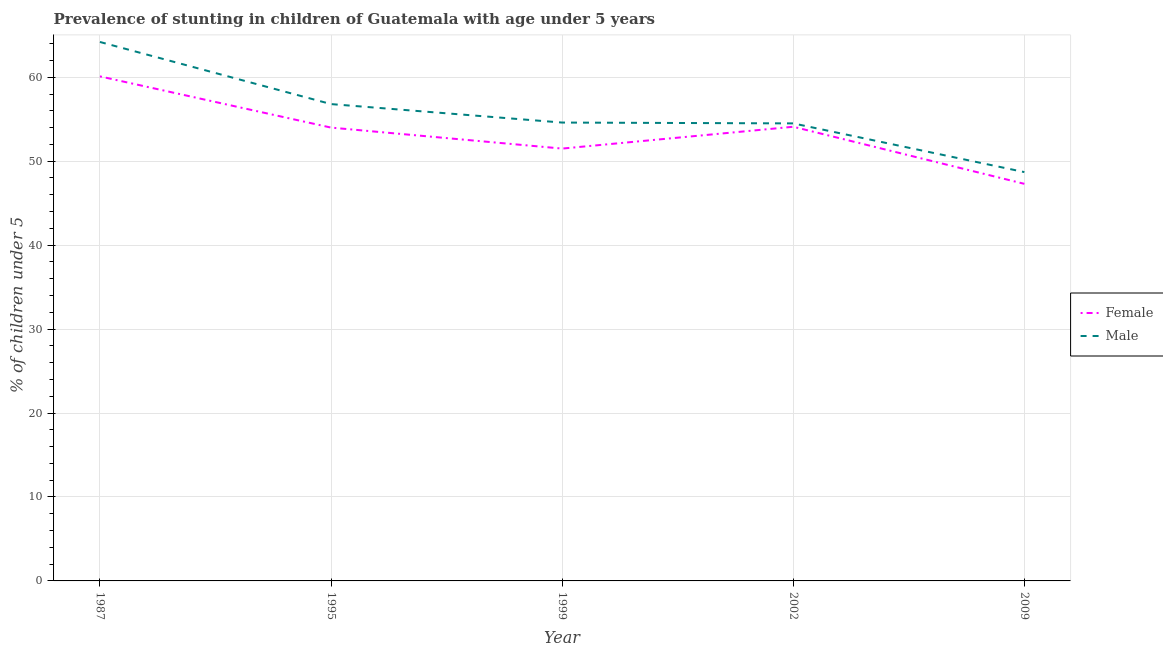Does the line corresponding to percentage of stunted male children intersect with the line corresponding to percentage of stunted female children?
Make the answer very short. No. Is the number of lines equal to the number of legend labels?
Your answer should be very brief. Yes. What is the percentage of stunted female children in 2009?
Give a very brief answer. 47.3. Across all years, what is the maximum percentage of stunted female children?
Offer a terse response. 60.1. Across all years, what is the minimum percentage of stunted male children?
Offer a very short reply. 48.7. What is the total percentage of stunted male children in the graph?
Offer a terse response. 278.8. What is the difference between the percentage of stunted male children in 1999 and that in 2009?
Keep it short and to the point. 5.9. What is the difference between the percentage of stunted male children in 2009 and the percentage of stunted female children in 1999?
Give a very brief answer. -2.8. What is the average percentage of stunted male children per year?
Offer a very short reply. 55.76. In the year 1999, what is the difference between the percentage of stunted female children and percentage of stunted male children?
Provide a short and direct response. -3.1. In how many years, is the percentage of stunted male children greater than 14 %?
Offer a very short reply. 5. What is the ratio of the percentage of stunted male children in 1995 to that in 2009?
Your response must be concise. 1.17. Is the difference between the percentage of stunted female children in 1995 and 2002 greater than the difference between the percentage of stunted male children in 1995 and 2002?
Your response must be concise. No. What is the difference between the highest and the second highest percentage of stunted male children?
Provide a short and direct response. 7.4. What is the difference between the highest and the lowest percentage of stunted female children?
Ensure brevity in your answer.  12.8. In how many years, is the percentage of stunted female children greater than the average percentage of stunted female children taken over all years?
Keep it short and to the point. 3. Is the percentage of stunted male children strictly greater than the percentage of stunted female children over the years?
Your answer should be compact. Yes. How many lines are there?
Make the answer very short. 2. What is the difference between two consecutive major ticks on the Y-axis?
Give a very brief answer. 10. Does the graph contain grids?
Provide a succinct answer. Yes. How many legend labels are there?
Your answer should be very brief. 2. What is the title of the graph?
Provide a short and direct response. Prevalence of stunting in children of Guatemala with age under 5 years. What is the label or title of the X-axis?
Give a very brief answer. Year. What is the label or title of the Y-axis?
Your response must be concise.  % of children under 5. What is the  % of children under 5 of Female in 1987?
Offer a very short reply. 60.1. What is the  % of children under 5 of Male in 1987?
Ensure brevity in your answer.  64.2. What is the  % of children under 5 in Male in 1995?
Make the answer very short. 56.8. What is the  % of children under 5 of Female in 1999?
Provide a succinct answer. 51.5. What is the  % of children under 5 in Male in 1999?
Make the answer very short. 54.6. What is the  % of children under 5 in Female in 2002?
Provide a short and direct response. 54.1. What is the  % of children under 5 in Male in 2002?
Your answer should be compact. 54.5. What is the  % of children under 5 in Female in 2009?
Offer a terse response. 47.3. What is the  % of children under 5 in Male in 2009?
Provide a short and direct response. 48.7. Across all years, what is the maximum  % of children under 5 in Female?
Your answer should be very brief. 60.1. Across all years, what is the maximum  % of children under 5 in Male?
Your answer should be very brief. 64.2. Across all years, what is the minimum  % of children under 5 of Female?
Your answer should be very brief. 47.3. Across all years, what is the minimum  % of children under 5 in Male?
Keep it short and to the point. 48.7. What is the total  % of children under 5 of Female in the graph?
Make the answer very short. 267. What is the total  % of children under 5 in Male in the graph?
Ensure brevity in your answer.  278.8. What is the difference between the  % of children under 5 in Female in 1987 and that in 1995?
Your response must be concise. 6.1. What is the difference between the  % of children under 5 of Female in 1987 and that in 2002?
Your response must be concise. 6. What is the difference between the  % of children under 5 in Male in 1987 and that in 2002?
Give a very brief answer. 9.7. What is the difference between the  % of children under 5 of Female in 1987 and that in 2009?
Make the answer very short. 12.8. What is the difference between the  % of children under 5 of Male in 1995 and that in 1999?
Provide a short and direct response. 2.2. What is the difference between the  % of children under 5 of Male in 1995 and that in 2009?
Your response must be concise. 8.1. What is the difference between the  % of children under 5 in Female in 1999 and that in 2002?
Your answer should be very brief. -2.6. What is the difference between the  % of children under 5 of Female in 1999 and that in 2009?
Your response must be concise. 4.2. What is the difference between the  % of children under 5 of Male in 1999 and that in 2009?
Keep it short and to the point. 5.9. What is the difference between the  % of children under 5 in Male in 2002 and that in 2009?
Ensure brevity in your answer.  5.8. What is the difference between the  % of children under 5 of Female in 1987 and the  % of children under 5 of Male in 1999?
Offer a terse response. 5.5. What is the difference between the  % of children under 5 of Female in 1995 and the  % of children under 5 of Male in 1999?
Offer a terse response. -0.6. What is the difference between the  % of children under 5 of Female in 1995 and the  % of children under 5 of Male in 2009?
Offer a very short reply. 5.3. What is the difference between the  % of children under 5 of Female in 1999 and the  % of children under 5 of Male in 2002?
Keep it short and to the point. -3. What is the difference between the  % of children under 5 in Female in 2002 and the  % of children under 5 in Male in 2009?
Keep it short and to the point. 5.4. What is the average  % of children under 5 of Female per year?
Your response must be concise. 53.4. What is the average  % of children under 5 in Male per year?
Your response must be concise. 55.76. In the year 2009, what is the difference between the  % of children under 5 in Female and  % of children under 5 in Male?
Give a very brief answer. -1.4. What is the ratio of the  % of children under 5 of Female in 1987 to that in 1995?
Ensure brevity in your answer.  1.11. What is the ratio of the  % of children under 5 in Male in 1987 to that in 1995?
Your answer should be very brief. 1.13. What is the ratio of the  % of children under 5 in Female in 1987 to that in 1999?
Give a very brief answer. 1.17. What is the ratio of the  % of children under 5 in Male in 1987 to that in 1999?
Provide a succinct answer. 1.18. What is the ratio of the  % of children under 5 in Female in 1987 to that in 2002?
Make the answer very short. 1.11. What is the ratio of the  % of children under 5 of Male in 1987 to that in 2002?
Offer a very short reply. 1.18. What is the ratio of the  % of children under 5 of Female in 1987 to that in 2009?
Give a very brief answer. 1.27. What is the ratio of the  % of children under 5 in Male in 1987 to that in 2009?
Offer a terse response. 1.32. What is the ratio of the  % of children under 5 in Female in 1995 to that in 1999?
Provide a short and direct response. 1.05. What is the ratio of the  % of children under 5 of Male in 1995 to that in 1999?
Your response must be concise. 1.04. What is the ratio of the  % of children under 5 of Male in 1995 to that in 2002?
Your answer should be very brief. 1.04. What is the ratio of the  % of children under 5 in Female in 1995 to that in 2009?
Give a very brief answer. 1.14. What is the ratio of the  % of children under 5 of Male in 1995 to that in 2009?
Provide a succinct answer. 1.17. What is the ratio of the  % of children under 5 in Female in 1999 to that in 2002?
Your answer should be very brief. 0.95. What is the ratio of the  % of children under 5 in Female in 1999 to that in 2009?
Give a very brief answer. 1.09. What is the ratio of the  % of children under 5 of Male in 1999 to that in 2009?
Offer a terse response. 1.12. What is the ratio of the  % of children under 5 in Female in 2002 to that in 2009?
Your answer should be very brief. 1.14. What is the ratio of the  % of children under 5 of Male in 2002 to that in 2009?
Keep it short and to the point. 1.12. What is the difference between the highest and the second highest  % of children under 5 of Male?
Provide a short and direct response. 7.4. What is the difference between the highest and the lowest  % of children under 5 in Male?
Provide a succinct answer. 15.5. 